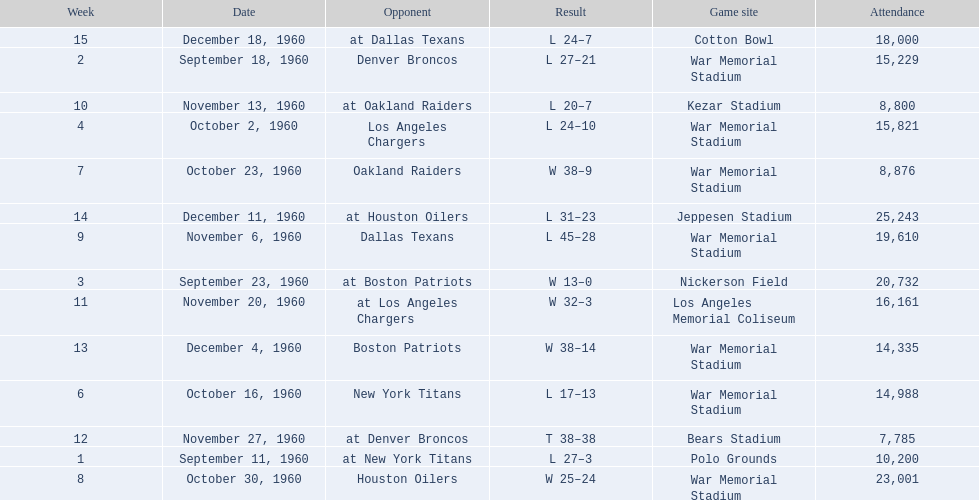Which date had the highest attendance? December 11, 1960. 